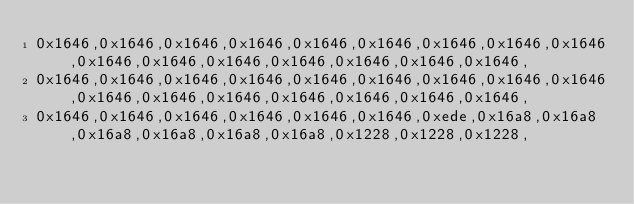Convert code to text. <code><loc_0><loc_0><loc_500><loc_500><_C_>0x1646,0x1646,0x1646,0x1646,0x1646,0x1646,0x1646,0x1646,0x1646,0x1646,0x1646,0x1646,0x1646,0x1646,0x1646,0x1646,
0x1646,0x1646,0x1646,0x1646,0x1646,0x1646,0x1646,0x1646,0x1646,0x1646,0x1646,0x1646,0x1646,0x1646,0x1646,0x1646,
0x1646,0x1646,0x1646,0x1646,0x1646,0x1646,0xede,0x16a8,0x16a8,0x16a8,0x16a8,0x16a8,0x16a8,0x1228,0x1228,0x1228,</code> 